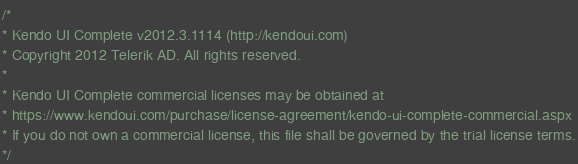<code> <loc_0><loc_0><loc_500><loc_500><_JavaScript_>/*
* Kendo UI Complete v2012.3.1114 (http://kendoui.com)
* Copyright 2012 Telerik AD. All rights reserved.
*
* Kendo UI Complete commercial licenses may be obtained at
* https://www.kendoui.com/purchase/license-agreement/kendo-ui-complete-commercial.aspx
* If you do not own a commercial license, this file shall be governed by the trial license terms.
*/</code> 